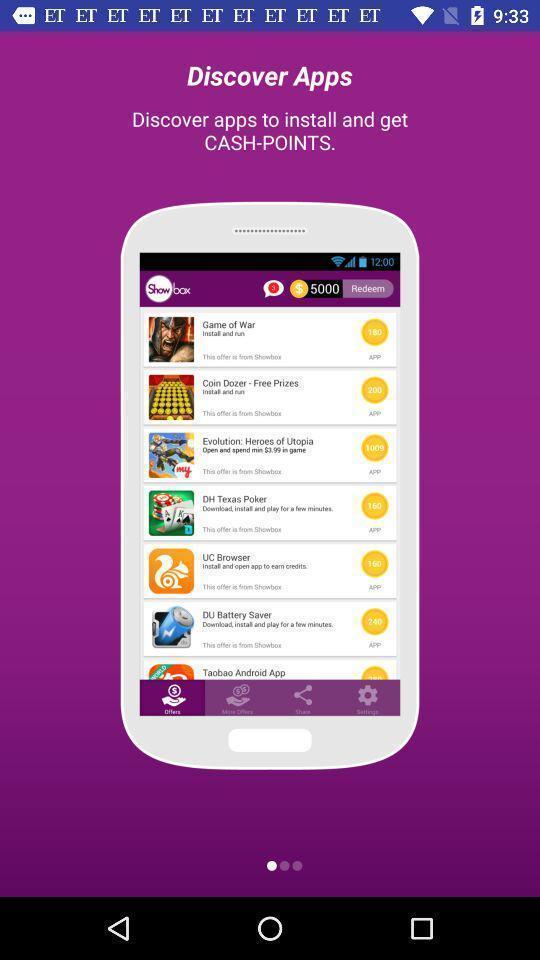What can you discern from this picture? Page showing information about to install. 